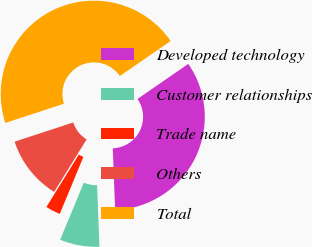<chart> <loc_0><loc_0><loc_500><loc_500><pie_chart><fcel>Developed technology<fcel>Customer relationships<fcel>Trade name<fcel>Others<fcel>Total<nl><fcel>34.0%<fcel>6.86%<fcel>2.57%<fcel>11.14%<fcel>45.43%<nl></chart> 